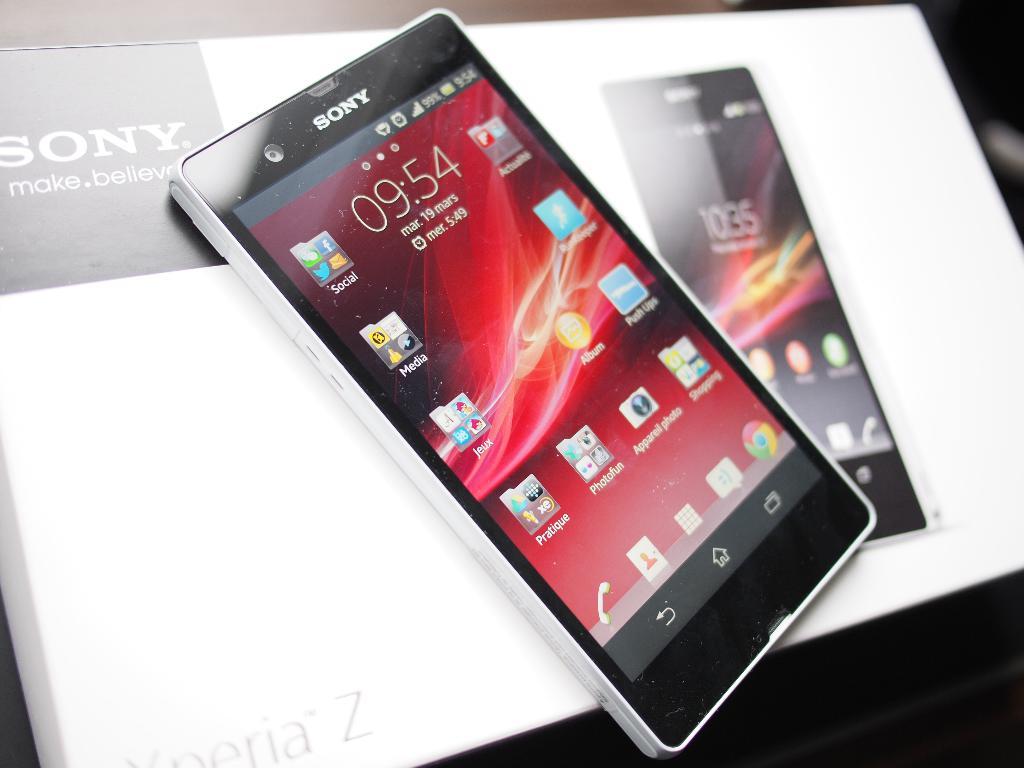What company made this smartphone?
Provide a succinct answer. Sony. What time does the phone read?
Offer a terse response. 09:54. 